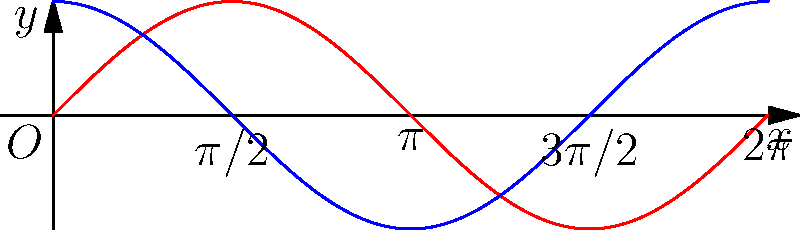As a fellow tournament champion, you're faced with a challenging equation that requires sophisticated manipulation of trigonometric identities. Prove that:

$$\frac{\sin^6 x + \cos^6 x}{\sin^2 x + \cos^2 x} = 1 - \frac{3}{4}\sin^2 2x$$

This equation is crucial for solving a complex problem in the upcoming championship. How would you approach this proof? Let's approach this step-by-step:

1) First, recall the fundamental trigonometric identity: $\sin^2 x + \cos^2 x = 1$

2) Now, let's focus on the left side of the equation:
   $$\frac{\sin^6 x + \cos^6 x}{\sin^2 x + \cos^2 x}$$

3) Using the identity from step 1, we can simplify the denominator to 1:
   $$\sin^6 x + \cos^6 x$$

4) Now, let's use the identity $(\sin^2 x + \cos^2 x)^3 = 1^3 = 1$:
   $$(\sin^2 x + \cos^2 x)^3 = \sin^6 x + 3\sin^4 x\cos^2 x + 3\sin^2 x\cos^4 x + \cos^6 x = 1$$

5) Rearranging this:
   $$\sin^6 x + \cos^6 x = 1 - 3\sin^4 x\cos^2 x - 3\sin^2 x\cos^4 x$$

6) Factor out $3\sin^2 x\cos^2 x$ from the right side:
   $$\sin^6 x + \cos^6 x = 1 - 3\sin^2 x\cos^2 x(\sin^2 x + \cos^2 x)$$

7) Again, $\sin^2 x + \cos^2 x = 1$, so:
   $$\sin^6 x + \cos^6 x = 1 - 3\sin^2 x\cos^2 x$$

8) Recall the double angle formula: $\sin^2 2x = 4\sin^2 x\cos^2 x$

9) Therefore, $\sin^2 x\cos^2 x = \frac{1}{4}\sin^2 2x$

10) Substituting this in:
    $$\sin^6 x + \cos^6 x = 1 - 3(\frac{1}{4}\sin^2 2x) = 1 - \frac{3}{4}\sin^2 2x$$

Thus, we have proved the original equation.
Answer: $\frac{\sin^6 x + \cos^6 x}{\sin^2 x + \cos^2 x} = 1 - \frac{3}{4}\sin^2 2x$ 